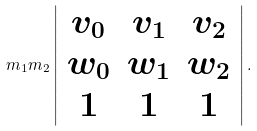<formula> <loc_0><loc_0><loc_500><loc_500>m _ { 1 } m _ { 2 } \left | \begin{array} { c c c } v _ { 0 } & v _ { 1 } & v _ { 2 } \\ w _ { 0 } & w _ { 1 } & w _ { 2 } \\ 1 & 1 & 1 \end{array} \right | .</formula> 